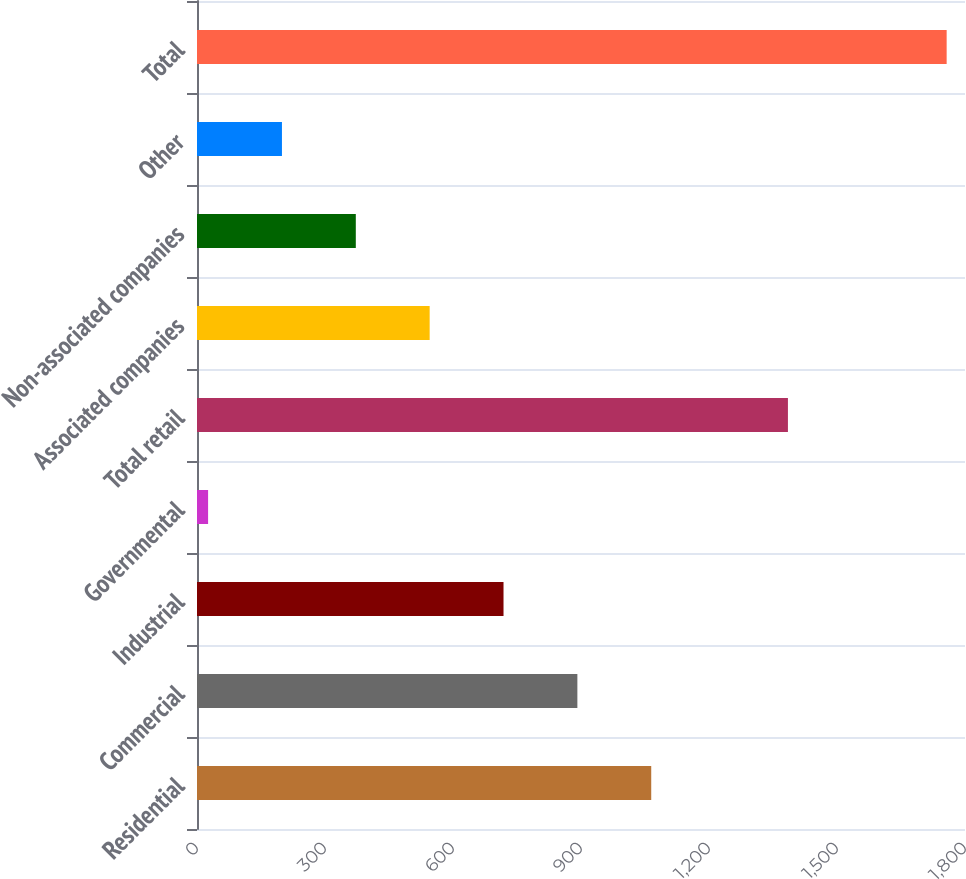<chart> <loc_0><loc_0><loc_500><loc_500><bar_chart><fcel>Residential<fcel>Commercial<fcel>Industrial<fcel>Governmental<fcel>Total retail<fcel>Associated companies<fcel>Non-associated companies<fcel>Other<fcel>Total<nl><fcel>1064.6<fcel>891.5<fcel>718.4<fcel>26<fcel>1385<fcel>545.3<fcel>372.2<fcel>199.1<fcel>1757<nl></chart> 